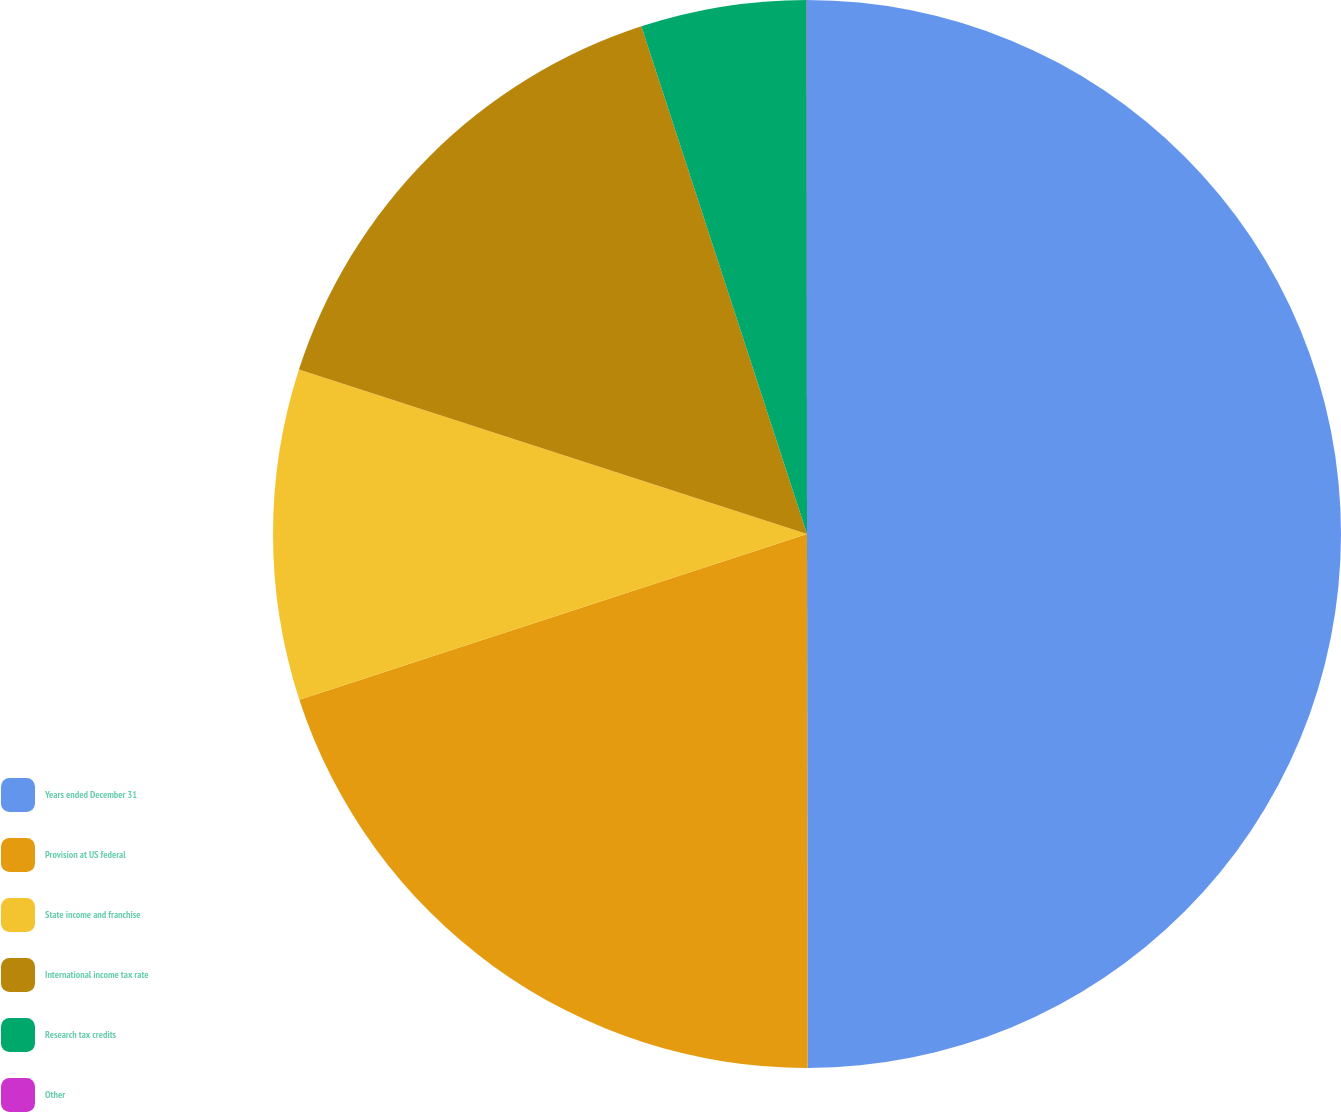Convert chart. <chart><loc_0><loc_0><loc_500><loc_500><pie_chart><fcel>Years ended December 31<fcel>Provision at US federal<fcel>State income and franchise<fcel>International income tax rate<fcel>Research tax credits<fcel>Other<nl><fcel>49.98%<fcel>20.0%<fcel>10.0%<fcel>15.0%<fcel>5.01%<fcel>0.01%<nl></chart> 